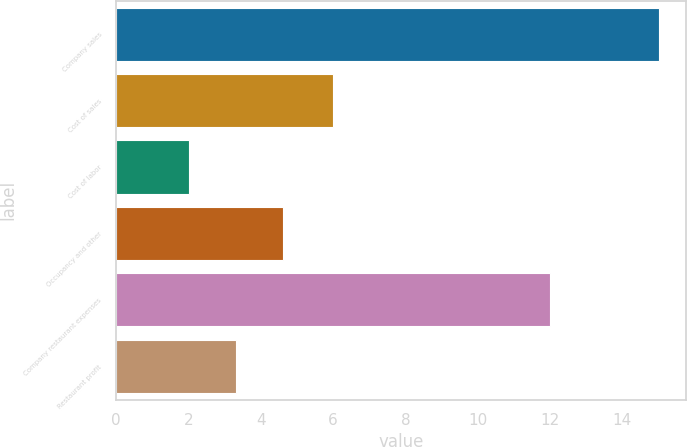Convert chart to OTSL. <chart><loc_0><loc_0><loc_500><loc_500><bar_chart><fcel>Company sales<fcel>Cost of sales<fcel>Cost of labor<fcel>Occupancy and other<fcel>Company restaurant expenses<fcel>Restaurant profit<nl><fcel>15<fcel>6<fcel>2<fcel>4.6<fcel>12<fcel>3.3<nl></chart> 